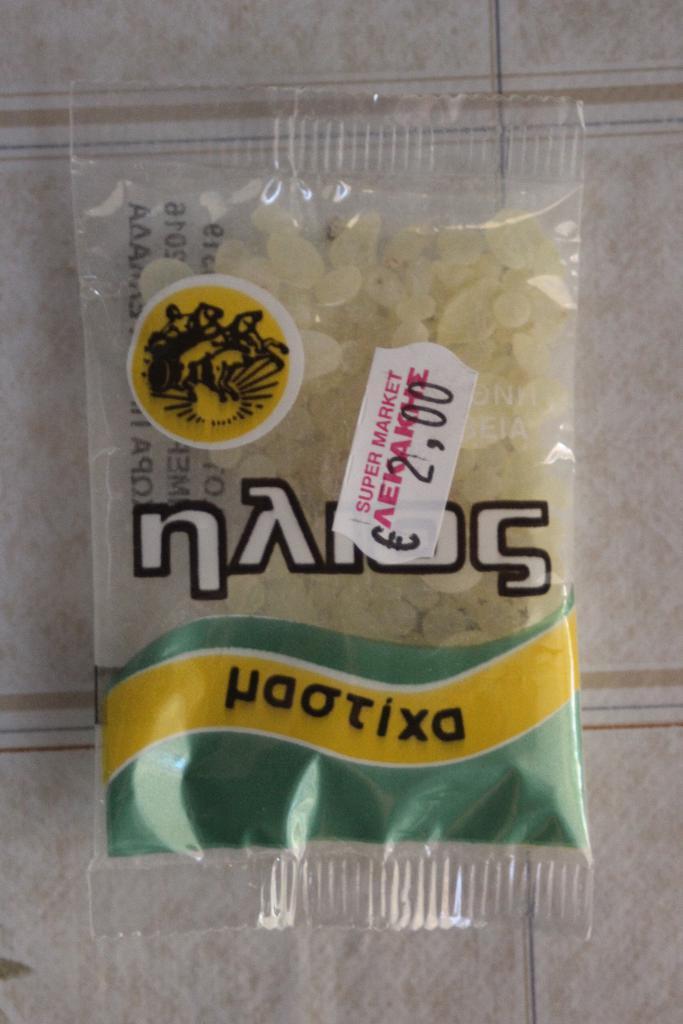Describe this image in one or two sentences. Here in this picture we can see some food item present in a packet, which is present on the floor over there. 